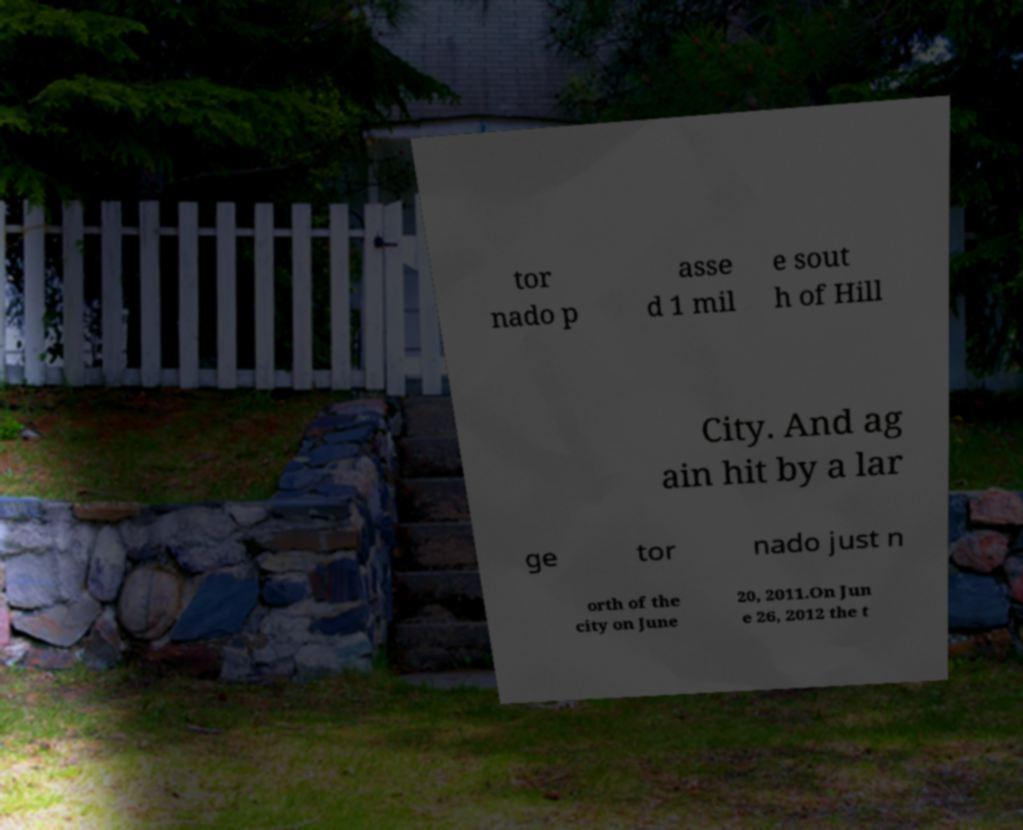What messages or text are displayed in this image? I need them in a readable, typed format. tor nado p asse d 1 mil e sout h of Hill City. And ag ain hit by a lar ge tor nado just n orth of the city on June 20, 2011.On Jun e 26, 2012 the t 